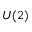<formula> <loc_0><loc_0><loc_500><loc_500>U ( 2 )</formula> 